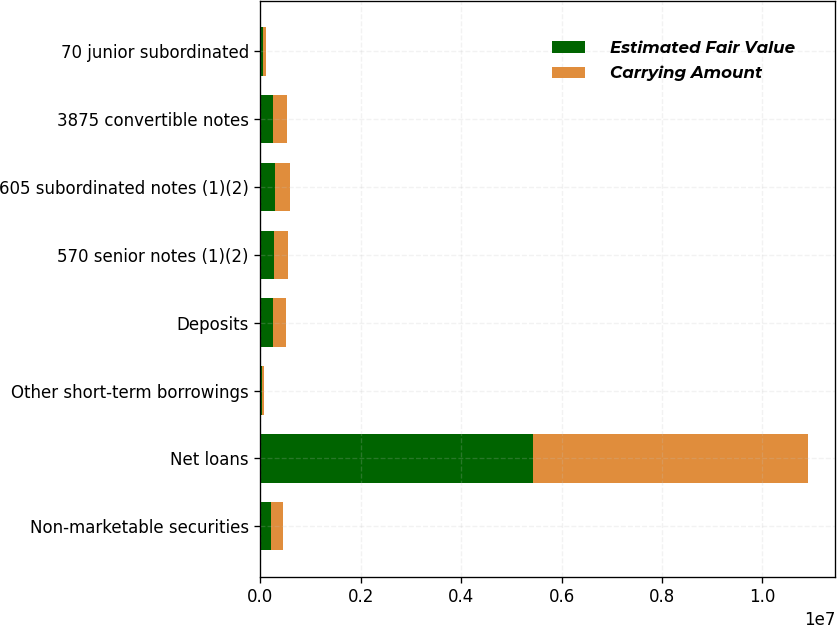Convert chart to OTSL. <chart><loc_0><loc_0><loc_500><loc_500><stacked_bar_chart><ecel><fcel>Non-marketable securities<fcel>Net loans<fcel>Other short-term borrowings<fcel>Deposits<fcel>570 senior notes (1)(2)<fcel>605 subordinated notes (1)(2)<fcel>3875 convertible notes<fcel>70 junior subordinated<nl><fcel>Estimated Fair Value<fcel>217449<fcel>5.43911e+06<fcel>37245<fcel>257458<fcel>265613<fcel>285937<fcel>249304<fcel>55548<nl><fcel>Carrying Amount<fcel>230158<fcel>5.46625e+06<fcel>37245<fcel>257458<fcel>277301<fcel>298101<fcel>276825<fcel>49485<nl></chart> 